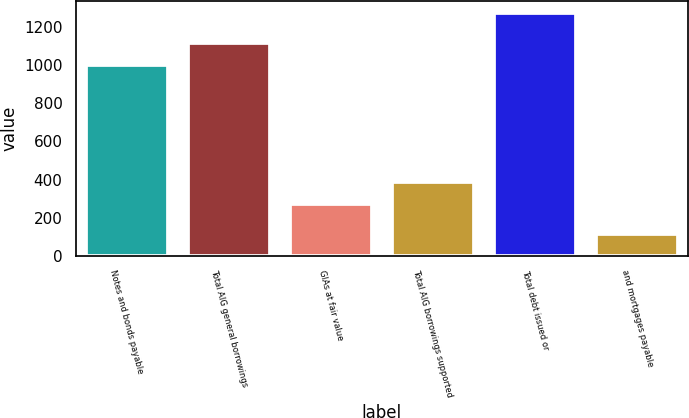Convert chart to OTSL. <chart><loc_0><loc_0><loc_500><loc_500><bar_chart><fcel>Notes and bonds payable<fcel>Total AIG general borrowings<fcel>GIAs at fair value<fcel>Total AIG borrowings supported<fcel>Total debt issued or<fcel>and mortgages payable<nl><fcel>999<fcel>1114.4<fcel>272<fcel>387.4<fcel>1271<fcel>117<nl></chart> 